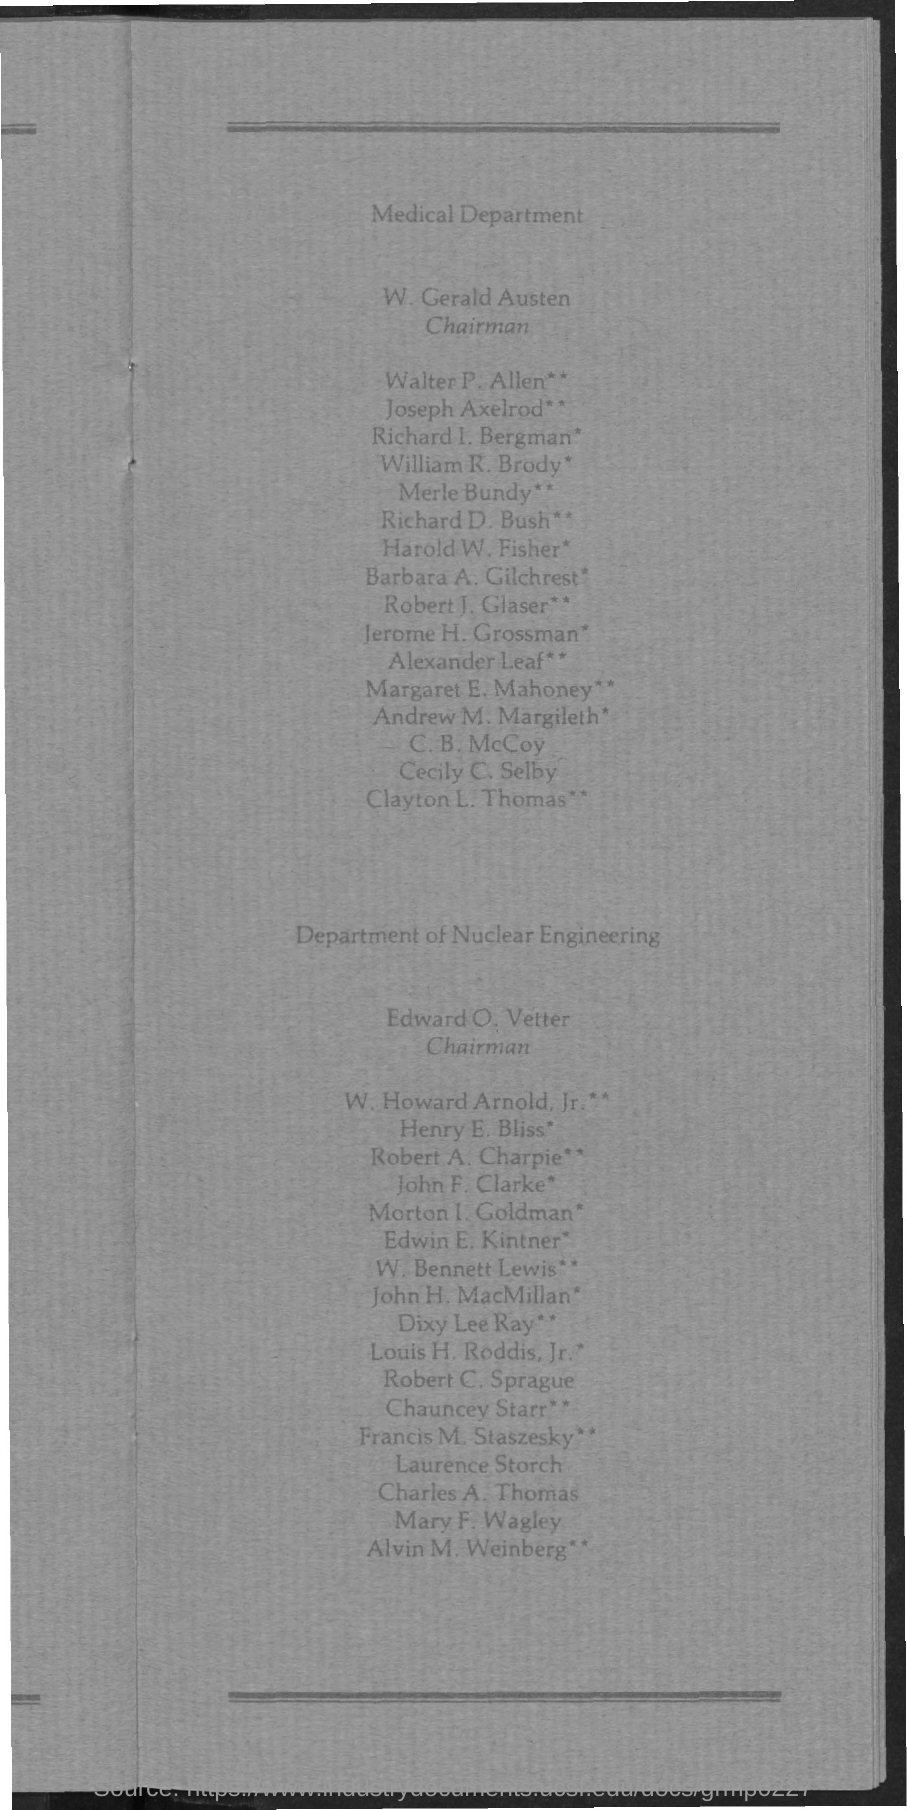Who is the Chairman of Nuclear Engineering?
Provide a succinct answer. Edward O. Vetter. 